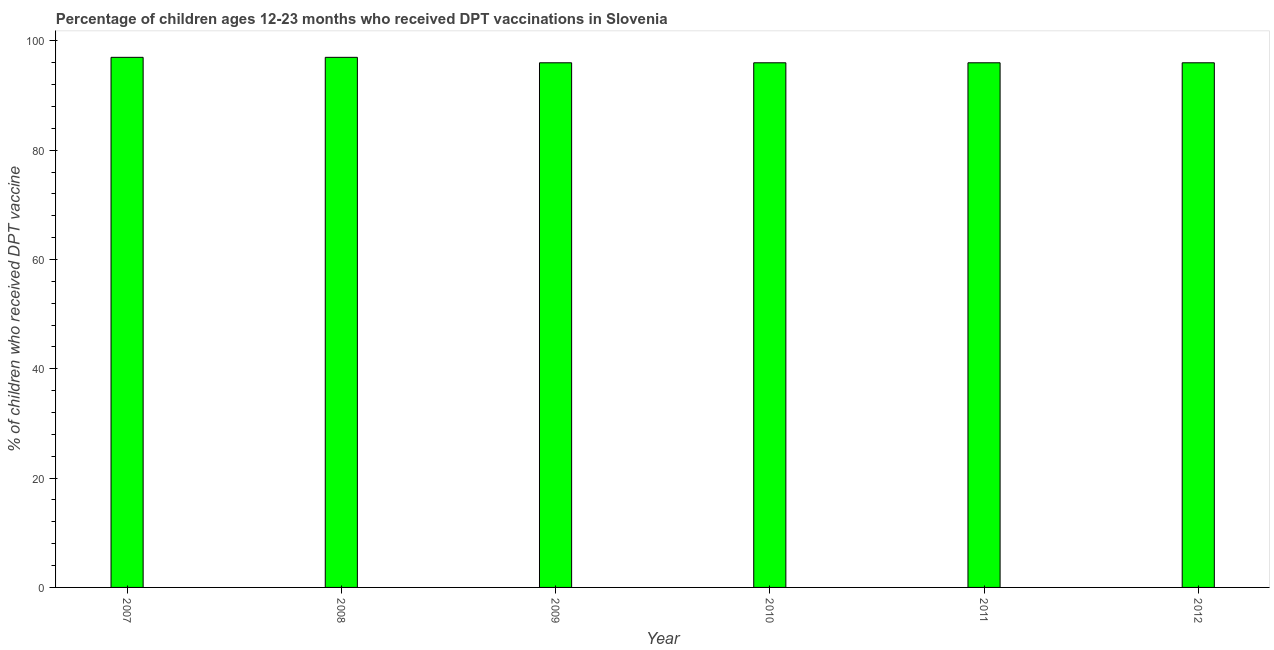What is the title of the graph?
Offer a terse response. Percentage of children ages 12-23 months who received DPT vaccinations in Slovenia. What is the label or title of the X-axis?
Provide a short and direct response. Year. What is the label or title of the Y-axis?
Offer a terse response. % of children who received DPT vaccine. What is the percentage of children who received dpt vaccine in 2011?
Your answer should be very brief. 96. Across all years, what is the maximum percentage of children who received dpt vaccine?
Provide a succinct answer. 97. Across all years, what is the minimum percentage of children who received dpt vaccine?
Give a very brief answer. 96. In which year was the percentage of children who received dpt vaccine maximum?
Keep it short and to the point. 2007. In which year was the percentage of children who received dpt vaccine minimum?
Provide a short and direct response. 2009. What is the sum of the percentage of children who received dpt vaccine?
Your response must be concise. 578. What is the difference between the percentage of children who received dpt vaccine in 2008 and 2012?
Keep it short and to the point. 1. What is the average percentage of children who received dpt vaccine per year?
Provide a succinct answer. 96. What is the median percentage of children who received dpt vaccine?
Offer a terse response. 96. In how many years, is the percentage of children who received dpt vaccine greater than 88 %?
Provide a short and direct response. 6. What is the ratio of the percentage of children who received dpt vaccine in 2007 to that in 2008?
Your answer should be very brief. 1. Is the percentage of children who received dpt vaccine in 2008 less than that in 2011?
Offer a terse response. No. Is the sum of the percentage of children who received dpt vaccine in 2008 and 2009 greater than the maximum percentage of children who received dpt vaccine across all years?
Make the answer very short. Yes. What is the difference between the highest and the lowest percentage of children who received dpt vaccine?
Your answer should be compact. 1. What is the difference between two consecutive major ticks on the Y-axis?
Make the answer very short. 20. Are the values on the major ticks of Y-axis written in scientific E-notation?
Provide a succinct answer. No. What is the % of children who received DPT vaccine in 2007?
Ensure brevity in your answer.  97. What is the % of children who received DPT vaccine of 2008?
Offer a terse response. 97. What is the % of children who received DPT vaccine of 2009?
Offer a very short reply. 96. What is the % of children who received DPT vaccine in 2010?
Your answer should be very brief. 96. What is the % of children who received DPT vaccine of 2011?
Your answer should be very brief. 96. What is the % of children who received DPT vaccine in 2012?
Provide a short and direct response. 96. What is the difference between the % of children who received DPT vaccine in 2007 and 2008?
Your answer should be compact. 0. What is the difference between the % of children who received DPT vaccine in 2007 and 2010?
Provide a short and direct response. 1. What is the difference between the % of children who received DPT vaccine in 2007 and 2012?
Offer a terse response. 1. What is the difference between the % of children who received DPT vaccine in 2008 and 2009?
Provide a short and direct response. 1. What is the difference between the % of children who received DPT vaccine in 2008 and 2011?
Provide a short and direct response. 1. What is the difference between the % of children who received DPT vaccine in 2008 and 2012?
Provide a short and direct response. 1. What is the difference between the % of children who received DPT vaccine in 2009 and 2012?
Offer a very short reply. 0. What is the difference between the % of children who received DPT vaccine in 2010 and 2011?
Make the answer very short. 0. What is the difference between the % of children who received DPT vaccine in 2010 and 2012?
Provide a succinct answer. 0. What is the difference between the % of children who received DPT vaccine in 2011 and 2012?
Your answer should be very brief. 0. What is the ratio of the % of children who received DPT vaccine in 2007 to that in 2008?
Provide a short and direct response. 1. What is the ratio of the % of children who received DPT vaccine in 2007 to that in 2009?
Provide a short and direct response. 1.01. What is the ratio of the % of children who received DPT vaccine in 2007 to that in 2010?
Your answer should be compact. 1.01. What is the ratio of the % of children who received DPT vaccine in 2007 to that in 2012?
Keep it short and to the point. 1.01. What is the ratio of the % of children who received DPT vaccine in 2008 to that in 2011?
Your response must be concise. 1.01. What is the ratio of the % of children who received DPT vaccine in 2009 to that in 2010?
Provide a succinct answer. 1. What is the ratio of the % of children who received DPT vaccine in 2009 to that in 2011?
Provide a succinct answer. 1. What is the ratio of the % of children who received DPT vaccine in 2010 to that in 2012?
Make the answer very short. 1. 